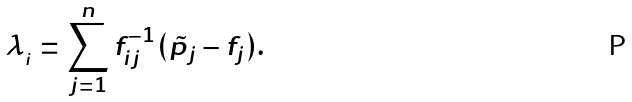<formula> <loc_0><loc_0><loc_500><loc_500>\lambda _ { _ { i } } = \sum _ { j = 1 } ^ { n } f ^ { - 1 } _ { i j } ( \tilde { p } _ { j } - f _ { j } ) { . }</formula> 